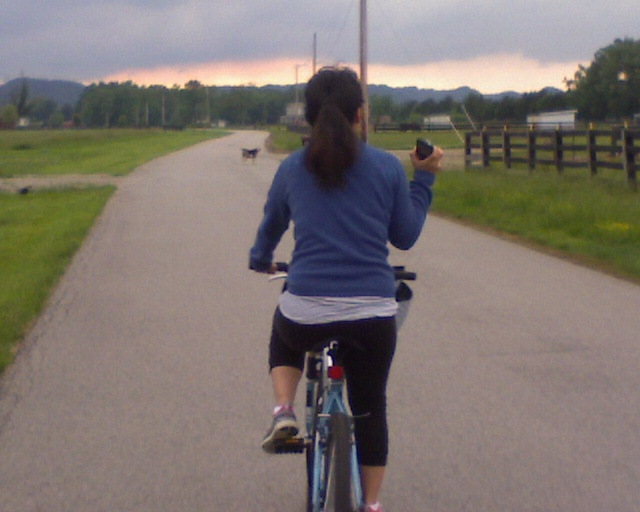Describe the objects in this image and their specific colors. I can see people in darkgray, black, navy, and gray tones, bicycle in darkgray, black, gray, navy, and maroon tones, cell phone in darkgray, black, and gray tones, dog in darkgray and gray tones, and bird in darkgray, gray, black, and darkgreen tones in this image. 